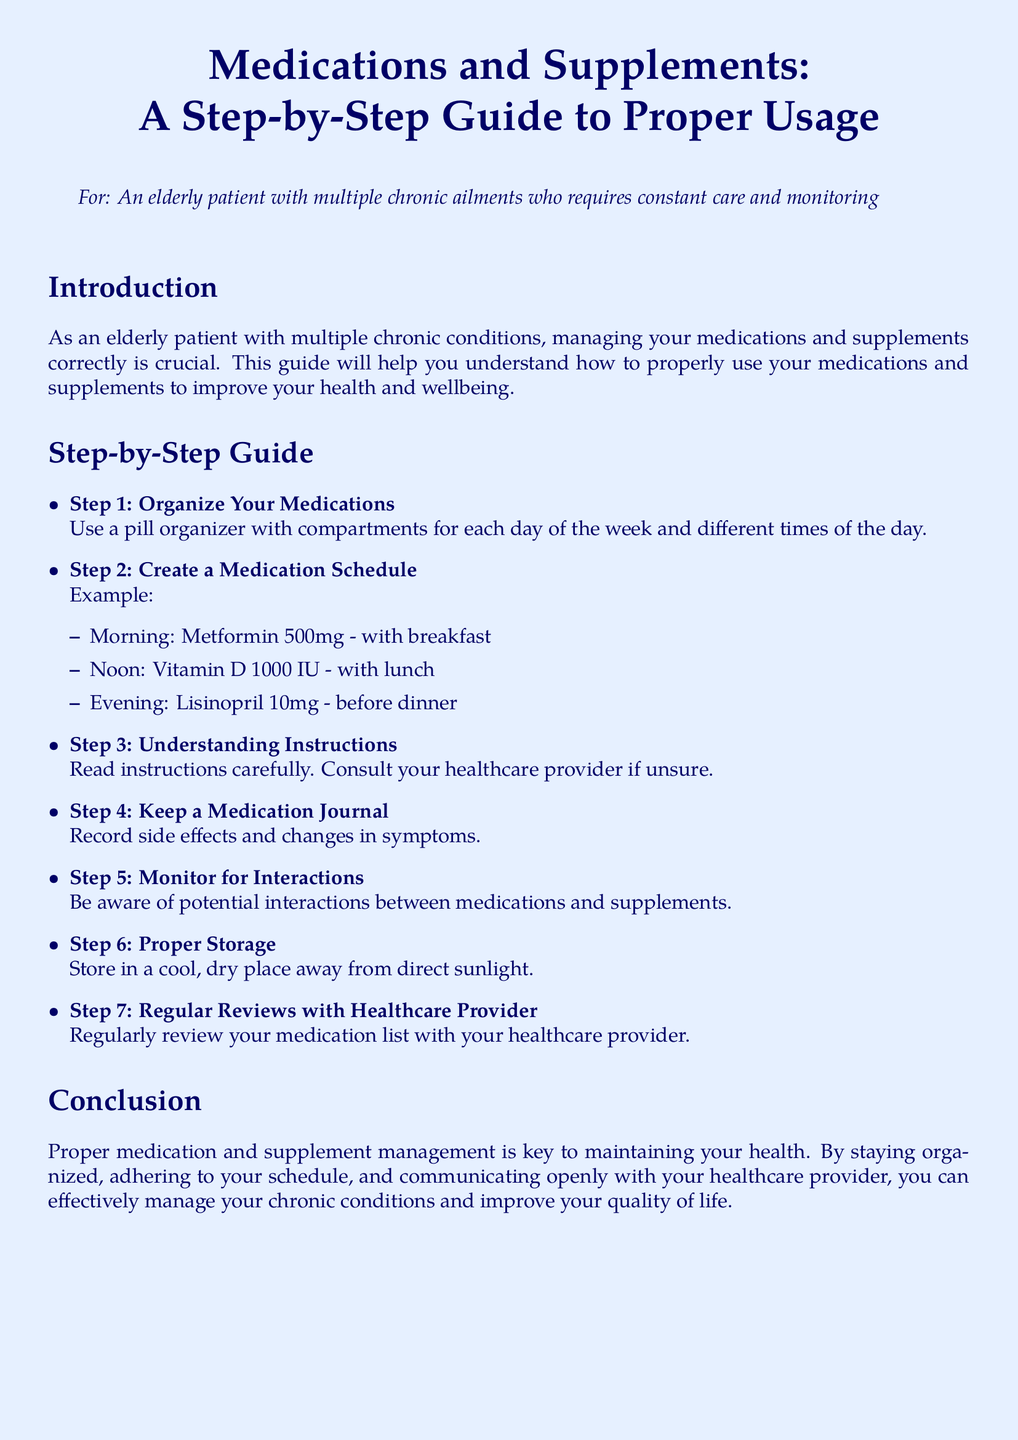What is the purpose of this guide? The purpose of the guide is to help elderly patients with multiple chronic conditions manage their medications and supplements correctly for improved health and wellbeing.
Answer: To improve health and wellbeing What is the first step in the guide? The first step outlined in the guide is to organize your medications using a pill organizer.
Answer: Organize Your Medications What medication should be taken at noon? The guide specifies taking Vitamin D 1000 IU with lunch at noon.
Answer: Vitamin D 1000 IU How many steps are outlined in the guide? The guide lists a total of 7 steps to manage medications and supplements.
Answer: 7 steps What should you record in a medication journal? The medication journal should include records of side effects and changes in symptoms.
Answer: Side effects and changes in symptoms What is important to monitor for interactions? It is important to be aware of potential interactions between medications and supplements.
Answer: Potential interactions How should medications be stored? Medications should be stored in a cool, dry place away from direct sunlight.
Answer: Cool, dry place away from sunlight Why is it important to regularly review your medication list? Regular reviews with a healthcare provider ensure proper management of medications.
Answer: Proper management of medications 